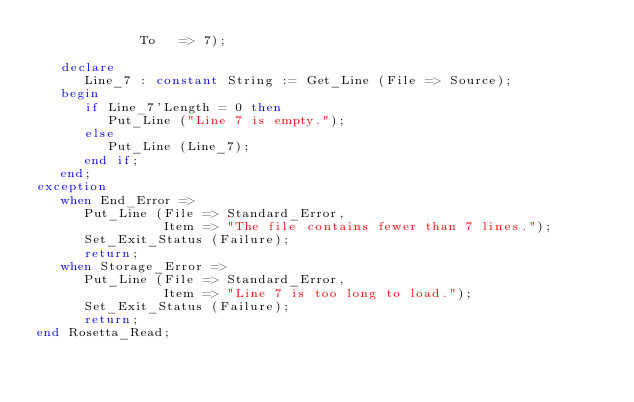<code> <loc_0><loc_0><loc_500><loc_500><_Ada_>             To   => 7);

   declare
      Line_7 : constant String := Get_Line (File => Source);
   begin
      if Line_7'Length = 0 then
         Put_Line ("Line 7 is empty.");
      else
         Put_Line (Line_7);
      end if;
   end;
exception
   when End_Error =>
      Put_Line (File => Standard_Error,
                Item => "The file contains fewer than 7 lines.");
      Set_Exit_Status (Failure);
      return;
   when Storage_Error =>
      Put_Line (File => Standard_Error,
                Item => "Line 7 is too long to load.");
      Set_Exit_Status (Failure);
      return;
end Rosetta_Read;
</code> 